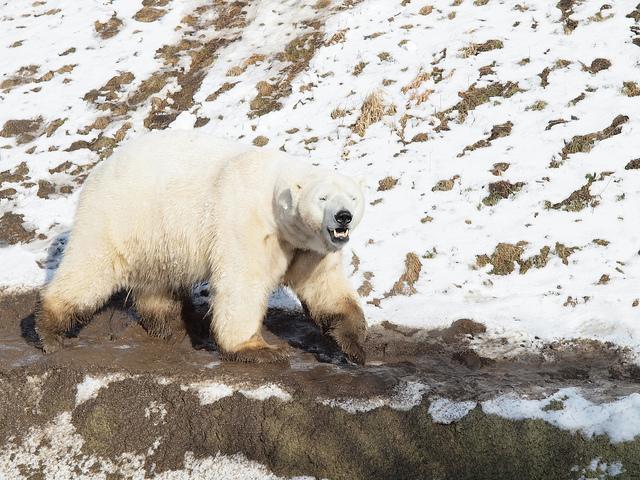How many people are holding a remote controller?
Give a very brief answer. 0. 